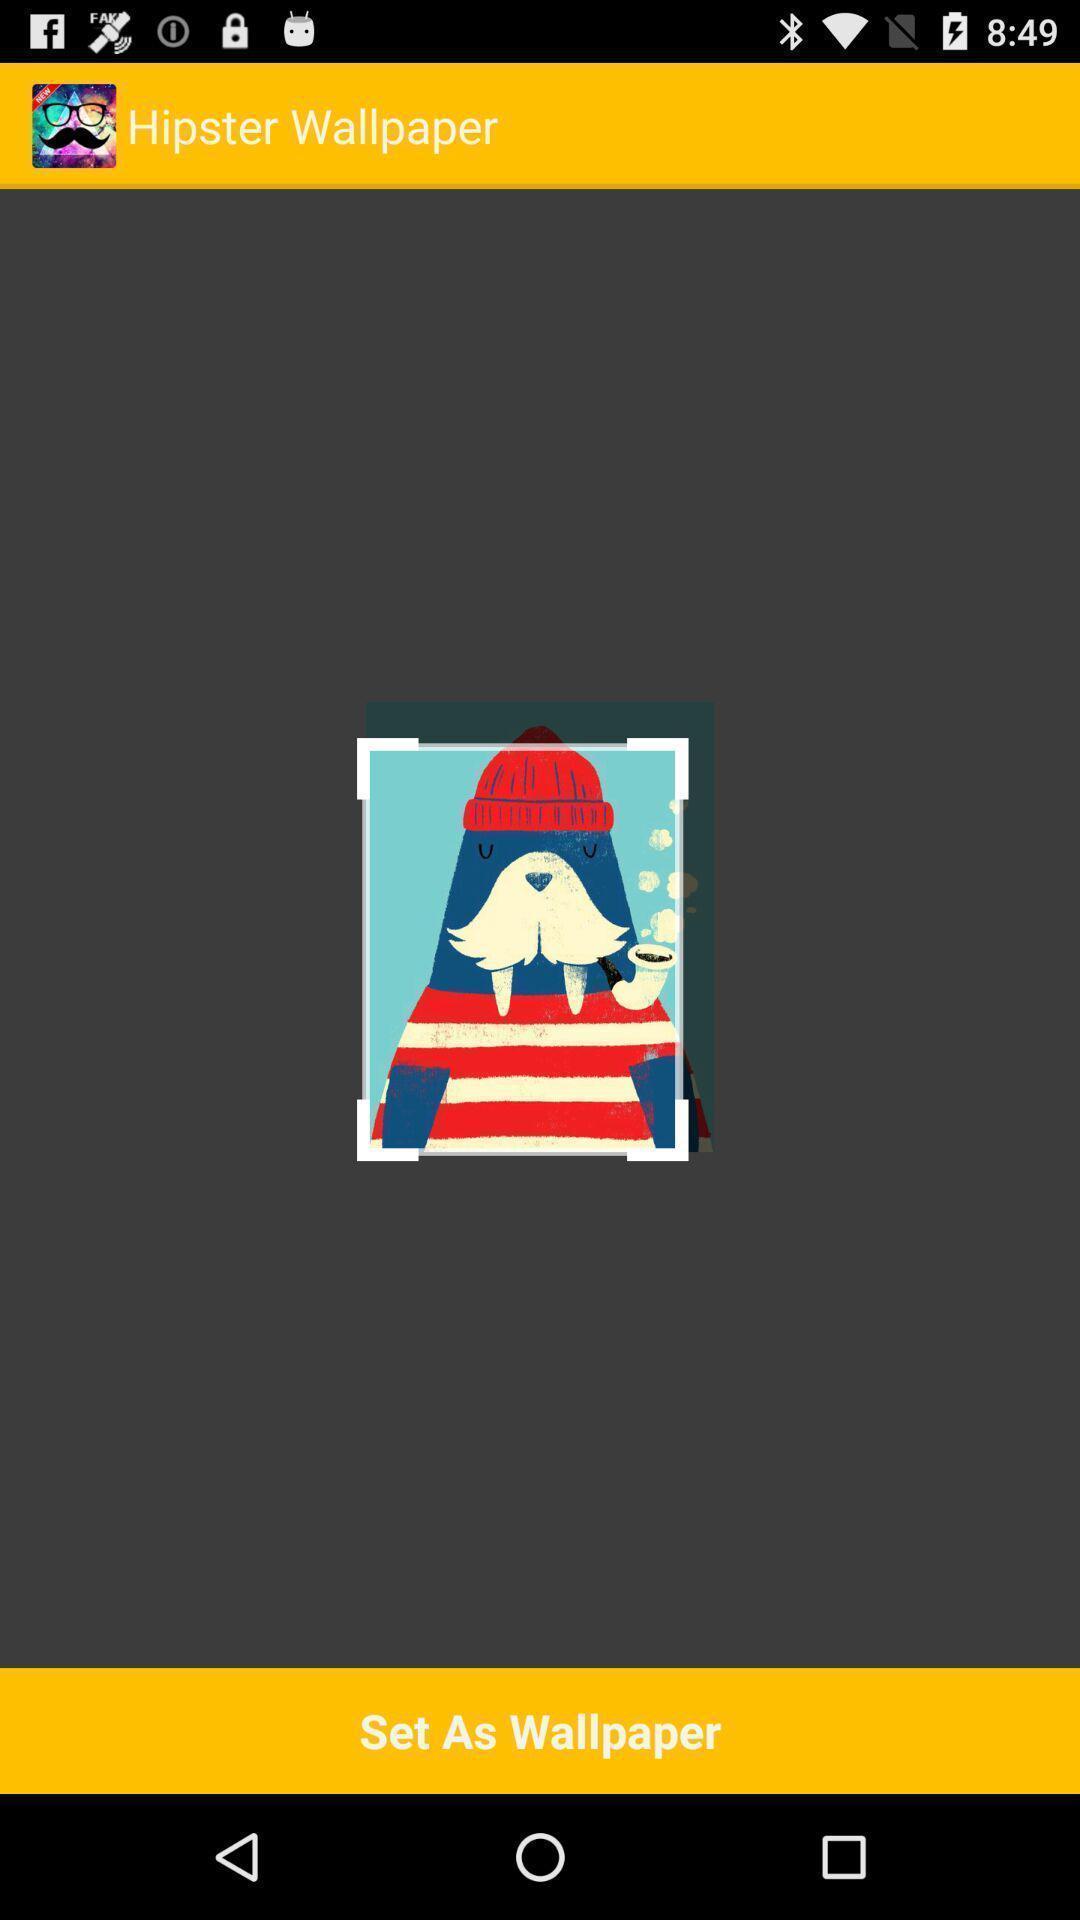Summarize the information in this screenshot. Page displaying an image to set as wallpaper. 